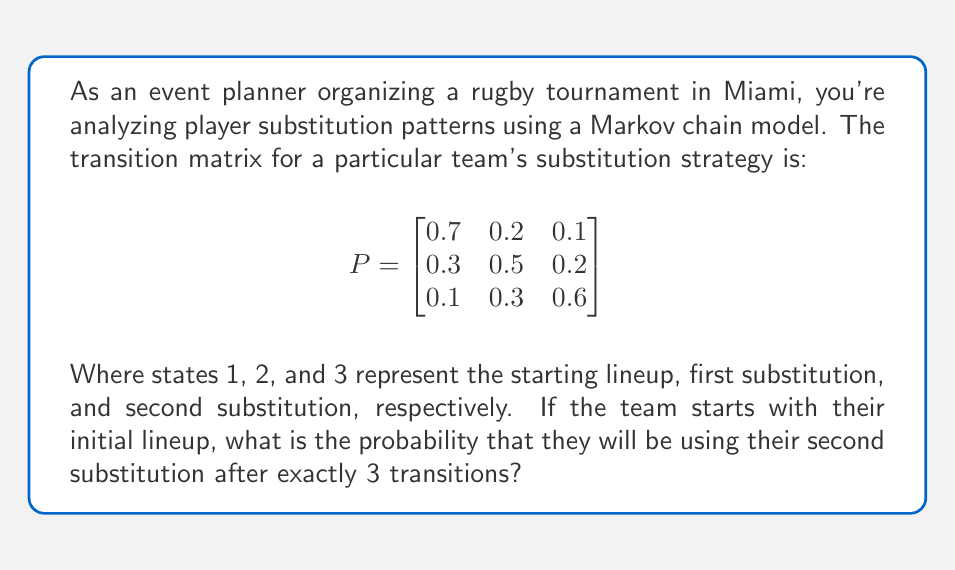Solve this math problem. To solve this problem, we need to use the Chapman-Kolmogorov equations and calculate the 3-step transition probability from state 1 to state 3. We can do this by raising the transition matrix to the power of 3 and looking at the element in the first row, third column.

Step 1: Calculate $P^3$
$$P^3 = P \cdot P \cdot P$$

Step 2: Multiply the matrices
$$P^2 = \begin{bmatrix}
0.7 & 0.2 & 0.1 \\
0.3 & 0.5 & 0.2 \\
0.1 & 0.3 & 0.6
\end{bmatrix} \cdot \begin{bmatrix}
0.7 & 0.2 & 0.1 \\
0.3 & 0.5 & 0.2 \\
0.1 & 0.3 & 0.6
\end{bmatrix} = \begin{bmatrix}
0.56 & 0.27 & 0.17 \\
0.37 & 0.39 & 0.24 \\
0.22 & 0.36 & 0.42
\end{bmatrix}$$

$$P^3 = P \cdot P^2 = \begin{bmatrix}
0.7 & 0.2 & 0.1 \\
0.3 & 0.5 & 0.2 \\
0.1 & 0.3 & 0.6
\end{bmatrix} \cdot \begin{bmatrix}
0.56 & 0.27 & 0.17 \\
0.37 & 0.39 & 0.24 \\
0.22 & 0.36 & 0.42
\end{bmatrix} = \begin{bmatrix}
0.497 & 0.305 & 0.198 \\
0.401 & 0.354 & 0.245 \\
0.289 & 0.363 & 0.348
\end{bmatrix}$$

Step 3: Identify the required probability
The probability of being in state 3 after 3 transitions, starting from state 1, is the element in the first row, third column of $P^3$, which is 0.198.
Answer: 0.198 